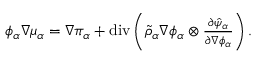Convert formula to latex. <formula><loc_0><loc_0><loc_500><loc_500>\begin{array} { r } { \phi _ { \alpha } \nabla \mu _ { \alpha } = \nabla \pi _ { \alpha } + d i v \left ( \tilde { \rho } _ { \alpha } \nabla \phi _ { \alpha } \otimes \frac { \partial \hat { \psi } _ { \alpha } } { \partial \nabla \phi _ { \alpha } } \right ) . } \end{array}</formula> 